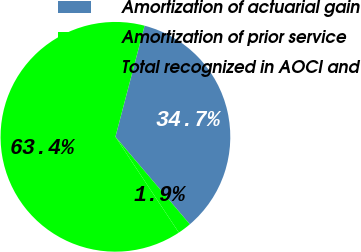Convert chart to OTSL. <chart><loc_0><loc_0><loc_500><loc_500><pie_chart><fcel>Amortization of actuarial gain<fcel>Amortization of prior service<fcel>Total recognized in AOCI and<nl><fcel>34.7%<fcel>1.91%<fcel>63.39%<nl></chart> 